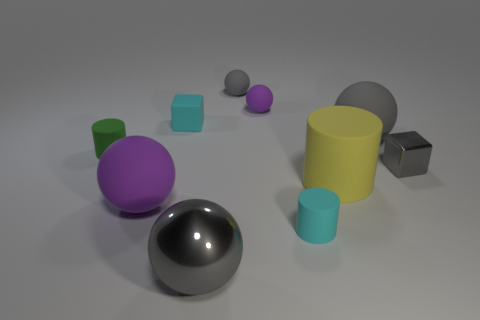Subtract all green cubes. How many gray spheres are left? 3 Subtract all metal spheres. How many spheres are left? 4 Subtract all yellow balls. Subtract all cyan cylinders. How many balls are left? 5 Subtract all cylinders. How many objects are left? 7 Add 5 gray blocks. How many gray blocks are left? 6 Add 2 brown metallic cylinders. How many brown metallic cylinders exist? 2 Subtract 1 cyan cylinders. How many objects are left? 9 Subtract all tiny brown shiny balls. Subtract all metallic spheres. How many objects are left? 9 